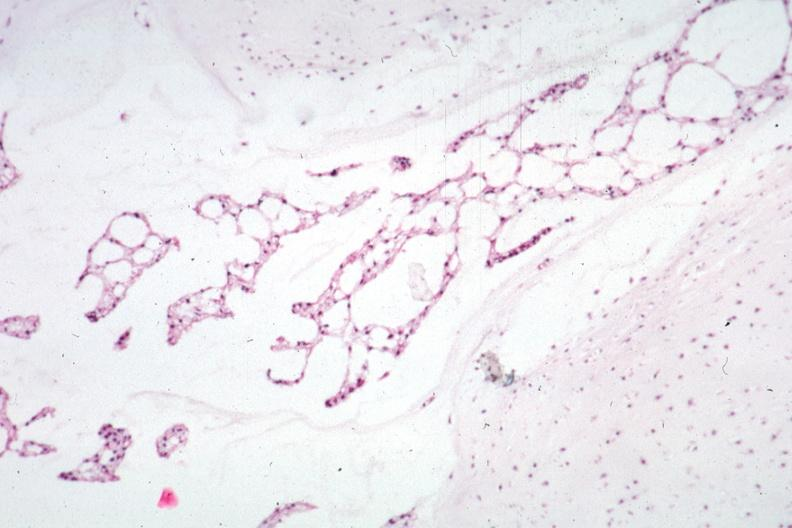s retroperitoneal liposarcoma present?
Answer the question using a single word or phrase. No 